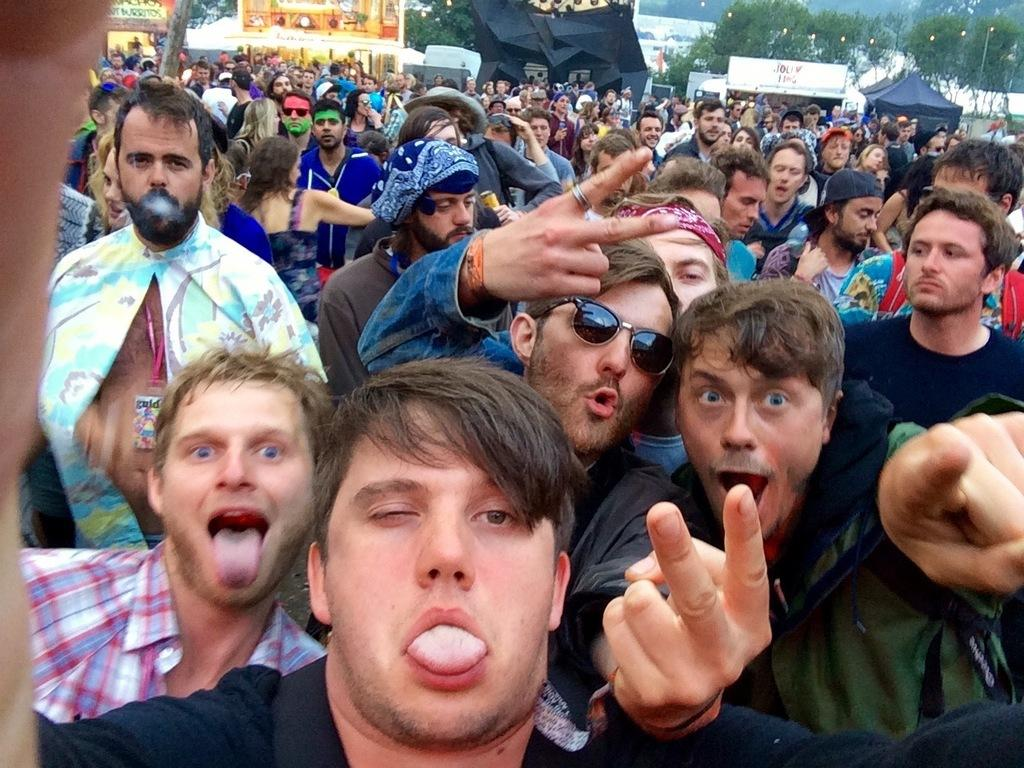What is the main subject of the image? The main subject of the image is a huge crowd. What can be seen in the background of the image? There are buildings, tents, and trees in the background of the image. What type of caption is written on the swing in the image? There is no swing present in the image, so there is no caption to be read. 